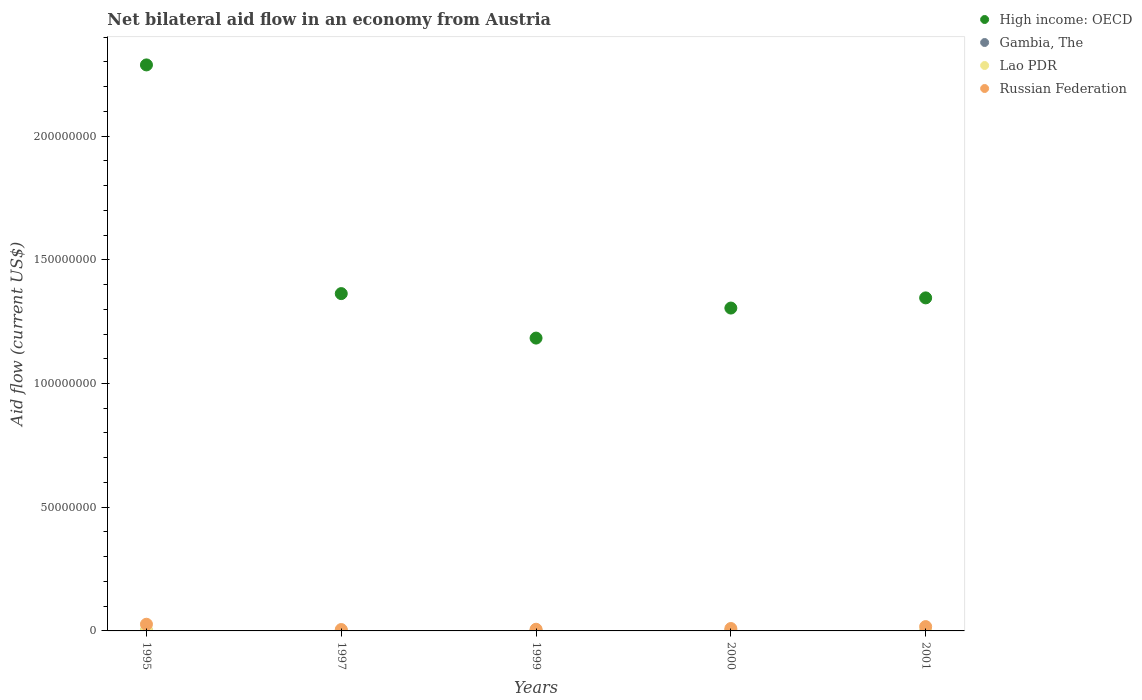Is the number of dotlines equal to the number of legend labels?
Offer a very short reply. No. What is the net bilateral aid flow in High income: OECD in 2001?
Offer a very short reply. 1.35e+08. Across all years, what is the maximum net bilateral aid flow in Lao PDR?
Provide a succinct answer. 4.00e+05. Across all years, what is the minimum net bilateral aid flow in Russian Federation?
Your answer should be compact. 5.60e+05. What is the total net bilateral aid flow in Russian Federation in the graph?
Ensure brevity in your answer.  6.66e+06. What is the difference between the net bilateral aid flow in Russian Federation in 1997 and that in 2001?
Give a very brief answer. -1.19e+06. What is the difference between the net bilateral aid flow in Lao PDR in 1995 and the net bilateral aid flow in Russian Federation in 2001?
Your answer should be very brief. -1.35e+06. What is the average net bilateral aid flow in High income: OECD per year?
Provide a succinct answer. 1.50e+08. In the year 1995, what is the difference between the net bilateral aid flow in High income: OECD and net bilateral aid flow in Russian Federation?
Keep it short and to the point. 2.26e+08. In how many years, is the net bilateral aid flow in Russian Federation greater than 50000000 US$?
Give a very brief answer. 0. What is the ratio of the net bilateral aid flow in Lao PDR in 1999 to that in 2000?
Make the answer very short. 0.33. Is the difference between the net bilateral aid flow in High income: OECD in 1995 and 1997 greater than the difference between the net bilateral aid flow in Russian Federation in 1995 and 1997?
Your answer should be very brief. Yes. What is the difference between the highest and the second highest net bilateral aid flow in Russian Federation?
Ensure brevity in your answer.  9.50e+05. What is the difference between the highest and the lowest net bilateral aid flow in Russian Federation?
Make the answer very short. 2.14e+06. In how many years, is the net bilateral aid flow in High income: OECD greater than the average net bilateral aid flow in High income: OECD taken over all years?
Offer a very short reply. 1. Is it the case that in every year, the sum of the net bilateral aid flow in Russian Federation and net bilateral aid flow in Lao PDR  is greater than the sum of net bilateral aid flow in Gambia, The and net bilateral aid flow in High income: OECD?
Provide a short and direct response. No. Does the net bilateral aid flow in Russian Federation monotonically increase over the years?
Make the answer very short. No. How many dotlines are there?
Ensure brevity in your answer.  4. Does the graph contain any zero values?
Ensure brevity in your answer.  Yes. Does the graph contain grids?
Ensure brevity in your answer.  No. Where does the legend appear in the graph?
Your answer should be compact. Top right. How are the legend labels stacked?
Give a very brief answer. Vertical. What is the title of the graph?
Your response must be concise. Net bilateral aid flow in an economy from Austria. Does "Marshall Islands" appear as one of the legend labels in the graph?
Your response must be concise. No. What is the label or title of the X-axis?
Offer a terse response. Years. What is the label or title of the Y-axis?
Ensure brevity in your answer.  Aid flow (current US$). What is the Aid flow (current US$) in High income: OECD in 1995?
Offer a terse response. 2.29e+08. What is the Aid flow (current US$) in Gambia, The in 1995?
Your answer should be compact. 10000. What is the Aid flow (current US$) in Russian Federation in 1995?
Provide a succinct answer. 2.70e+06. What is the Aid flow (current US$) of High income: OECD in 1997?
Provide a succinct answer. 1.36e+08. What is the Aid flow (current US$) in Gambia, The in 1997?
Your answer should be very brief. 0. What is the Aid flow (current US$) in Russian Federation in 1997?
Offer a terse response. 5.60e+05. What is the Aid flow (current US$) in High income: OECD in 1999?
Your answer should be very brief. 1.18e+08. What is the Aid flow (current US$) in Russian Federation in 1999?
Offer a very short reply. 6.80e+05. What is the Aid flow (current US$) in High income: OECD in 2000?
Provide a short and direct response. 1.30e+08. What is the Aid flow (current US$) of Russian Federation in 2000?
Ensure brevity in your answer.  9.70e+05. What is the Aid flow (current US$) in High income: OECD in 2001?
Your answer should be very brief. 1.35e+08. What is the Aid flow (current US$) of Gambia, The in 2001?
Keep it short and to the point. 0. What is the Aid flow (current US$) of Lao PDR in 2001?
Provide a short and direct response. 4.00e+04. What is the Aid flow (current US$) in Russian Federation in 2001?
Offer a very short reply. 1.75e+06. Across all years, what is the maximum Aid flow (current US$) in High income: OECD?
Give a very brief answer. 2.29e+08. Across all years, what is the maximum Aid flow (current US$) in Gambia, The?
Ensure brevity in your answer.  7.00e+04. Across all years, what is the maximum Aid flow (current US$) of Russian Federation?
Give a very brief answer. 2.70e+06. Across all years, what is the minimum Aid flow (current US$) in High income: OECD?
Offer a terse response. 1.18e+08. Across all years, what is the minimum Aid flow (current US$) in Gambia, The?
Give a very brief answer. 0. Across all years, what is the minimum Aid flow (current US$) in Lao PDR?
Your response must be concise. 10000. Across all years, what is the minimum Aid flow (current US$) in Russian Federation?
Offer a very short reply. 5.60e+05. What is the total Aid flow (current US$) of High income: OECD in the graph?
Offer a very short reply. 7.49e+08. What is the total Aid flow (current US$) of Gambia, The in the graph?
Provide a short and direct response. 1.50e+05. What is the total Aid flow (current US$) of Lao PDR in the graph?
Give a very brief answer. 5.10e+05. What is the total Aid flow (current US$) of Russian Federation in the graph?
Your answer should be very brief. 6.66e+06. What is the difference between the Aid flow (current US$) of High income: OECD in 1995 and that in 1997?
Offer a terse response. 9.24e+07. What is the difference between the Aid flow (current US$) of Lao PDR in 1995 and that in 1997?
Provide a succinct answer. 3.70e+05. What is the difference between the Aid flow (current US$) of Russian Federation in 1995 and that in 1997?
Provide a short and direct response. 2.14e+06. What is the difference between the Aid flow (current US$) in High income: OECD in 1995 and that in 1999?
Offer a very short reply. 1.10e+08. What is the difference between the Aid flow (current US$) of Gambia, The in 1995 and that in 1999?
Give a very brief answer. -6.00e+04. What is the difference between the Aid flow (current US$) in Lao PDR in 1995 and that in 1999?
Your answer should be very brief. 3.90e+05. What is the difference between the Aid flow (current US$) of Russian Federation in 1995 and that in 1999?
Your answer should be compact. 2.02e+06. What is the difference between the Aid flow (current US$) in High income: OECD in 1995 and that in 2000?
Your response must be concise. 9.83e+07. What is the difference between the Aid flow (current US$) of Lao PDR in 1995 and that in 2000?
Provide a succinct answer. 3.70e+05. What is the difference between the Aid flow (current US$) of Russian Federation in 1995 and that in 2000?
Give a very brief answer. 1.73e+06. What is the difference between the Aid flow (current US$) in High income: OECD in 1995 and that in 2001?
Make the answer very short. 9.42e+07. What is the difference between the Aid flow (current US$) in Lao PDR in 1995 and that in 2001?
Ensure brevity in your answer.  3.60e+05. What is the difference between the Aid flow (current US$) of Russian Federation in 1995 and that in 2001?
Offer a terse response. 9.50e+05. What is the difference between the Aid flow (current US$) in High income: OECD in 1997 and that in 1999?
Provide a succinct answer. 1.80e+07. What is the difference between the Aid flow (current US$) in High income: OECD in 1997 and that in 2000?
Provide a succinct answer. 5.84e+06. What is the difference between the Aid flow (current US$) in Russian Federation in 1997 and that in 2000?
Give a very brief answer. -4.10e+05. What is the difference between the Aid flow (current US$) of High income: OECD in 1997 and that in 2001?
Offer a terse response. 1.73e+06. What is the difference between the Aid flow (current US$) in Russian Federation in 1997 and that in 2001?
Ensure brevity in your answer.  -1.19e+06. What is the difference between the Aid flow (current US$) of High income: OECD in 1999 and that in 2000?
Your answer should be very brief. -1.21e+07. What is the difference between the Aid flow (current US$) in Gambia, The in 1999 and that in 2000?
Your answer should be compact. 0. What is the difference between the Aid flow (current US$) of Russian Federation in 1999 and that in 2000?
Provide a succinct answer. -2.90e+05. What is the difference between the Aid flow (current US$) of High income: OECD in 1999 and that in 2001?
Keep it short and to the point. -1.62e+07. What is the difference between the Aid flow (current US$) of Russian Federation in 1999 and that in 2001?
Keep it short and to the point. -1.07e+06. What is the difference between the Aid flow (current US$) of High income: OECD in 2000 and that in 2001?
Provide a succinct answer. -4.11e+06. What is the difference between the Aid flow (current US$) in Lao PDR in 2000 and that in 2001?
Provide a short and direct response. -10000. What is the difference between the Aid flow (current US$) of Russian Federation in 2000 and that in 2001?
Ensure brevity in your answer.  -7.80e+05. What is the difference between the Aid flow (current US$) in High income: OECD in 1995 and the Aid flow (current US$) in Lao PDR in 1997?
Ensure brevity in your answer.  2.29e+08. What is the difference between the Aid flow (current US$) of High income: OECD in 1995 and the Aid flow (current US$) of Russian Federation in 1997?
Your answer should be very brief. 2.28e+08. What is the difference between the Aid flow (current US$) of Gambia, The in 1995 and the Aid flow (current US$) of Russian Federation in 1997?
Your answer should be very brief. -5.50e+05. What is the difference between the Aid flow (current US$) in Lao PDR in 1995 and the Aid flow (current US$) in Russian Federation in 1997?
Ensure brevity in your answer.  -1.60e+05. What is the difference between the Aid flow (current US$) of High income: OECD in 1995 and the Aid flow (current US$) of Gambia, The in 1999?
Provide a succinct answer. 2.29e+08. What is the difference between the Aid flow (current US$) in High income: OECD in 1995 and the Aid flow (current US$) in Lao PDR in 1999?
Offer a very short reply. 2.29e+08. What is the difference between the Aid flow (current US$) in High income: OECD in 1995 and the Aid flow (current US$) in Russian Federation in 1999?
Keep it short and to the point. 2.28e+08. What is the difference between the Aid flow (current US$) of Gambia, The in 1995 and the Aid flow (current US$) of Russian Federation in 1999?
Your response must be concise. -6.70e+05. What is the difference between the Aid flow (current US$) in Lao PDR in 1995 and the Aid flow (current US$) in Russian Federation in 1999?
Offer a very short reply. -2.80e+05. What is the difference between the Aid flow (current US$) of High income: OECD in 1995 and the Aid flow (current US$) of Gambia, The in 2000?
Your answer should be very brief. 2.29e+08. What is the difference between the Aid flow (current US$) of High income: OECD in 1995 and the Aid flow (current US$) of Lao PDR in 2000?
Make the answer very short. 2.29e+08. What is the difference between the Aid flow (current US$) in High income: OECD in 1995 and the Aid flow (current US$) in Russian Federation in 2000?
Keep it short and to the point. 2.28e+08. What is the difference between the Aid flow (current US$) of Gambia, The in 1995 and the Aid flow (current US$) of Russian Federation in 2000?
Offer a very short reply. -9.60e+05. What is the difference between the Aid flow (current US$) in Lao PDR in 1995 and the Aid flow (current US$) in Russian Federation in 2000?
Offer a very short reply. -5.70e+05. What is the difference between the Aid flow (current US$) of High income: OECD in 1995 and the Aid flow (current US$) of Lao PDR in 2001?
Your response must be concise. 2.29e+08. What is the difference between the Aid flow (current US$) of High income: OECD in 1995 and the Aid flow (current US$) of Russian Federation in 2001?
Your response must be concise. 2.27e+08. What is the difference between the Aid flow (current US$) of Gambia, The in 1995 and the Aid flow (current US$) of Lao PDR in 2001?
Make the answer very short. -3.00e+04. What is the difference between the Aid flow (current US$) of Gambia, The in 1995 and the Aid flow (current US$) of Russian Federation in 2001?
Make the answer very short. -1.74e+06. What is the difference between the Aid flow (current US$) in Lao PDR in 1995 and the Aid flow (current US$) in Russian Federation in 2001?
Offer a very short reply. -1.35e+06. What is the difference between the Aid flow (current US$) of High income: OECD in 1997 and the Aid flow (current US$) of Gambia, The in 1999?
Your response must be concise. 1.36e+08. What is the difference between the Aid flow (current US$) in High income: OECD in 1997 and the Aid flow (current US$) in Lao PDR in 1999?
Offer a very short reply. 1.36e+08. What is the difference between the Aid flow (current US$) of High income: OECD in 1997 and the Aid flow (current US$) of Russian Federation in 1999?
Your answer should be compact. 1.36e+08. What is the difference between the Aid flow (current US$) in Lao PDR in 1997 and the Aid flow (current US$) in Russian Federation in 1999?
Provide a succinct answer. -6.50e+05. What is the difference between the Aid flow (current US$) of High income: OECD in 1997 and the Aid flow (current US$) of Gambia, The in 2000?
Keep it short and to the point. 1.36e+08. What is the difference between the Aid flow (current US$) of High income: OECD in 1997 and the Aid flow (current US$) of Lao PDR in 2000?
Give a very brief answer. 1.36e+08. What is the difference between the Aid flow (current US$) of High income: OECD in 1997 and the Aid flow (current US$) of Russian Federation in 2000?
Provide a succinct answer. 1.35e+08. What is the difference between the Aid flow (current US$) in Lao PDR in 1997 and the Aid flow (current US$) in Russian Federation in 2000?
Offer a very short reply. -9.40e+05. What is the difference between the Aid flow (current US$) of High income: OECD in 1997 and the Aid flow (current US$) of Lao PDR in 2001?
Provide a short and direct response. 1.36e+08. What is the difference between the Aid flow (current US$) in High income: OECD in 1997 and the Aid flow (current US$) in Russian Federation in 2001?
Provide a short and direct response. 1.35e+08. What is the difference between the Aid flow (current US$) of Lao PDR in 1997 and the Aid flow (current US$) of Russian Federation in 2001?
Offer a very short reply. -1.72e+06. What is the difference between the Aid flow (current US$) of High income: OECD in 1999 and the Aid flow (current US$) of Gambia, The in 2000?
Keep it short and to the point. 1.18e+08. What is the difference between the Aid flow (current US$) in High income: OECD in 1999 and the Aid flow (current US$) in Lao PDR in 2000?
Give a very brief answer. 1.18e+08. What is the difference between the Aid flow (current US$) in High income: OECD in 1999 and the Aid flow (current US$) in Russian Federation in 2000?
Your answer should be compact. 1.17e+08. What is the difference between the Aid flow (current US$) of Gambia, The in 1999 and the Aid flow (current US$) of Lao PDR in 2000?
Your answer should be compact. 4.00e+04. What is the difference between the Aid flow (current US$) in Gambia, The in 1999 and the Aid flow (current US$) in Russian Federation in 2000?
Ensure brevity in your answer.  -9.00e+05. What is the difference between the Aid flow (current US$) of Lao PDR in 1999 and the Aid flow (current US$) of Russian Federation in 2000?
Your answer should be compact. -9.60e+05. What is the difference between the Aid flow (current US$) of High income: OECD in 1999 and the Aid flow (current US$) of Lao PDR in 2001?
Your response must be concise. 1.18e+08. What is the difference between the Aid flow (current US$) of High income: OECD in 1999 and the Aid flow (current US$) of Russian Federation in 2001?
Offer a terse response. 1.17e+08. What is the difference between the Aid flow (current US$) of Gambia, The in 1999 and the Aid flow (current US$) of Lao PDR in 2001?
Offer a terse response. 3.00e+04. What is the difference between the Aid flow (current US$) of Gambia, The in 1999 and the Aid flow (current US$) of Russian Federation in 2001?
Your response must be concise. -1.68e+06. What is the difference between the Aid flow (current US$) of Lao PDR in 1999 and the Aid flow (current US$) of Russian Federation in 2001?
Keep it short and to the point. -1.74e+06. What is the difference between the Aid flow (current US$) of High income: OECD in 2000 and the Aid flow (current US$) of Lao PDR in 2001?
Offer a very short reply. 1.30e+08. What is the difference between the Aid flow (current US$) of High income: OECD in 2000 and the Aid flow (current US$) of Russian Federation in 2001?
Offer a terse response. 1.29e+08. What is the difference between the Aid flow (current US$) of Gambia, The in 2000 and the Aid flow (current US$) of Russian Federation in 2001?
Offer a terse response. -1.68e+06. What is the difference between the Aid flow (current US$) of Lao PDR in 2000 and the Aid flow (current US$) of Russian Federation in 2001?
Ensure brevity in your answer.  -1.72e+06. What is the average Aid flow (current US$) in High income: OECD per year?
Give a very brief answer. 1.50e+08. What is the average Aid flow (current US$) of Lao PDR per year?
Your response must be concise. 1.02e+05. What is the average Aid flow (current US$) of Russian Federation per year?
Provide a short and direct response. 1.33e+06. In the year 1995, what is the difference between the Aid flow (current US$) in High income: OECD and Aid flow (current US$) in Gambia, The?
Offer a terse response. 2.29e+08. In the year 1995, what is the difference between the Aid flow (current US$) of High income: OECD and Aid flow (current US$) of Lao PDR?
Ensure brevity in your answer.  2.28e+08. In the year 1995, what is the difference between the Aid flow (current US$) in High income: OECD and Aid flow (current US$) in Russian Federation?
Your answer should be compact. 2.26e+08. In the year 1995, what is the difference between the Aid flow (current US$) in Gambia, The and Aid flow (current US$) in Lao PDR?
Your response must be concise. -3.90e+05. In the year 1995, what is the difference between the Aid flow (current US$) of Gambia, The and Aid flow (current US$) of Russian Federation?
Give a very brief answer. -2.69e+06. In the year 1995, what is the difference between the Aid flow (current US$) in Lao PDR and Aid flow (current US$) in Russian Federation?
Ensure brevity in your answer.  -2.30e+06. In the year 1997, what is the difference between the Aid flow (current US$) of High income: OECD and Aid flow (current US$) of Lao PDR?
Give a very brief answer. 1.36e+08. In the year 1997, what is the difference between the Aid flow (current US$) of High income: OECD and Aid flow (current US$) of Russian Federation?
Make the answer very short. 1.36e+08. In the year 1997, what is the difference between the Aid flow (current US$) of Lao PDR and Aid flow (current US$) of Russian Federation?
Your answer should be compact. -5.30e+05. In the year 1999, what is the difference between the Aid flow (current US$) in High income: OECD and Aid flow (current US$) in Gambia, The?
Your answer should be compact. 1.18e+08. In the year 1999, what is the difference between the Aid flow (current US$) of High income: OECD and Aid flow (current US$) of Lao PDR?
Keep it short and to the point. 1.18e+08. In the year 1999, what is the difference between the Aid flow (current US$) in High income: OECD and Aid flow (current US$) in Russian Federation?
Your answer should be very brief. 1.18e+08. In the year 1999, what is the difference between the Aid flow (current US$) of Gambia, The and Aid flow (current US$) of Russian Federation?
Offer a very short reply. -6.10e+05. In the year 1999, what is the difference between the Aid flow (current US$) in Lao PDR and Aid flow (current US$) in Russian Federation?
Your answer should be compact. -6.70e+05. In the year 2000, what is the difference between the Aid flow (current US$) of High income: OECD and Aid flow (current US$) of Gambia, The?
Make the answer very short. 1.30e+08. In the year 2000, what is the difference between the Aid flow (current US$) of High income: OECD and Aid flow (current US$) of Lao PDR?
Your response must be concise. 1.30e+08. In the year 2000, what is the difference between the Aid flow (current US$) in High income: OECD and Aid flow (current US$) in Russian Federation?
Make the answer very short. 1.30e+08. In the year 2000, what is the difference between the Aid flow (current US$) in Gambia, The and Aid flow (current US$) in Russian Federation?
Give a very brief answer. -9.00e+05. In the year 2000, what is the difference between the Aid flow (current US$) of Lao PDR and Aid flow (current US$) of Russian Federation?
Keep it short and to the point. -9.40e+05. In the year 2001, what is the difference between the Aid flow (current US$) in High income: OECD and Aid flow (current US$) in Lao PDR?
Provide a short and direct response. 1.35e+08. In the year 2001, what is the difference between the Aid flow (current US$) of High income: OECD and Aid flow (current US$) of Russian Federation?
Your answer should be very brief. 1.33e+08. In the year 2001, what is the difference between the Aid flow (current US$) of Lao PDR and Aid flow (current US$) of Russian Federation?
Ensure brevity in your answer.  -1.71e+06. What is the ratio of the Aid flow (current US$) in High income: OECD in 1995 to that in 1997?
Make the answer very short. 1.68. What is the ratio of the Aid flow (current US$) of Lao PDR in 1995 to that in 1997?
Give a very brief answer. 13.33. What is the ratio of the Aid flow (current US$) of Russian Federation in 1995 to that in 1997?
Make the answer very short. 4.82. What is the ratio of the Aid flow (current US$) of High income: OECD in 1995 to that in 1999?
Provide a short and direct response. 1.93. What is the ratio of the Aid flow (current US$) in Gambia, The in 1995 to that in 1999?
Keep it short and to the point. 0.14. What is the ratio of the Aid flow (current US$) of Russian Federation in 1995 to that in 1999?
Offer a very short reply. 3.97. What is the ratio of the Aid flow (current US$) of High income: OECD in 1995 to that in 2000?
Provide a short and direct response. 1.75. What is the ratio of the Aid flow (current US$) of Gambia, The in 1995 to that in 2000?
Provide a succinct answer. 0.14. What is the ratio of the Aid flow (current US$) in Lao PDR in 1995 to that in 2000?
Provide a short and direct response. 13.33. What is the ratio of the Aid flow (current US$) of Russian Federation in 1995 to that in 2000?
Ensure brevity in your answer.  2.78. What is the ratio of the Aid flow (current US$) of High income: OECD in 1995 to that in 2001?
Provide a succinct answer. 1.7. What is the ratio of the Aid flow (current US$) in Lao PDR in 1995 to that in 2001?
Your answer should be compact. 10. What is the ratio of the Aid flow (current US$) in Russian Federation in 1995 to that in 2001?
Give a very brief answer. 1.54. What is the ratio of the Aid flow (current US$) in High income: OECD in 1997 to that in 1999?
Keep it short and to the point. 1.15. What is the ratio of the Aid flow (current US$) of Russian Federation in 1997 to that in 1999?
Offer a very short reply. 0.82. What is the ratio of the Aid flow (current US$) of High income: OECD in 1997 to that in 2000?
Your response must be concise. 1.04. What is the ratio of the Aid flow (current US$) of Lao PDR in 1997 to that in 2000?
Keep it short and to the point. 1. What is the ratio of the Aid flow (current US$) of Russian Federation in 1997 to that in 2000?
Ensure brevity in your answer.  0.58. What is the ratio of the Aid flow (current US$) in High income: OECD in 1997 to that in 2001?
Your answer should be very brief. 1.01. What is the ratio of the Aid flow (current US$) of Lao PDR in 1997 to that in 2001?
Provide a short and direct response. 0.75. What is the ratio of the Aid flow (current US$) of Russian Federation in 1997 to that in 2001?
Offer a terse response. 0.32. What is the ratio of the Aid flow (current US$) of High income: OECD in 1999 to that in 2000?
Make the answer very short. 0.91. What is the ratio of the Aid flow (current US$) of Lao PDR in 1999 to that in 2000?
Your answer should be compact. 0.33. What is the ratio of the Aid flow (current US$) in Russian Federation in 1999 to that in 2000?
Give a very brief answer. 0.7. What is the ratio of the Aid flow (current US$) in High income: OECD in 1999 to that in 2001?
Make the answer very short. 0.88. What is the ratio of the Aid flow (current US$) of Russian Federation in 1999 to that in 2001?
Make the answer very short. 0.39. What is the ratio of the Aid flow (current US$) of High income: OECD in 2000 to that in 2001?
Your answer should be compact. 0.97. What is the ratio of the Aid flow (current US$) of Russian Federation in 2000 to that in 2001?
Offer a terse response. 0.55. What is the difference between the highest and the second highest Aid flow (current US$) of High income: OECD?
Provide a short and direct response. 9.24e+07. What is the difference between the highest and the second highest Aid flow (current US$) in Lao PDR?
Offer a very short reply. 3.60e+05. What is the difference between the highest and the second highest Aid flow (current US$) of Russian Federation?
Your answer should be very brief. 9.50e+05. What is the difference between the highest and the lowest Aid flow (current US$) in High income: OECD?
Offer a very short reply. 1.10e+08. What is the difference between the highest and the lowest Aid flow (current US$) in Lao PDR?
Give a very brief answer. 3.90e+05. What is the difference between the highest and the lowest Aid flow (current US$) in Russian Federation?
Make the answer very short. 2.14e+06. 